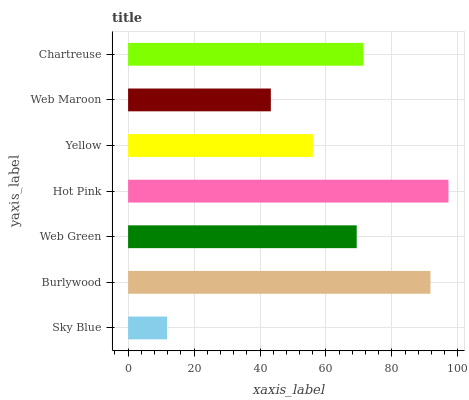Is Sky Blue the minimum?
Answer yes or no. Yes. Is Hot Pink the maximum?
Answer yes or no. Yes. Is Burlywood the minimum?
Answer yes or no. No. Is Burlywood the maximum?
Answer yes or no. No. Is Burlywood greater than Sky Blue?
Answer yes or no. Yes. Is Sky Blue less than Burlywood?
Answer yes or no. Yes. Is Sky Blue greater than Burlywood?
Answer yes or no. No. Is Burlywood less than Sky Blue?
Answer yes or no. No. Is Web Green the high median?
Answer yes or no. Yes. Is Web Green the low median?
Answer yes or no. Yes. Is Burlywood the high median?
Answer yes or no. No. Is Yellow the low median?
Answer yes or no. No. 